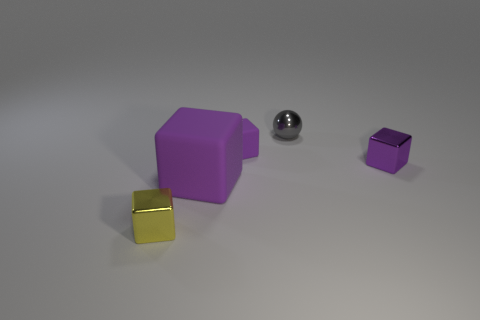How many purple cubes must be subtracted to get 1 purple cubes? 2 Subtract all small yellow blocks. How many blocks are left? 3 Add 1 large cyan cubes. How many objects exist? 6 Subtract all yellow blocks. How many blocks are left? 3 Subtract all balls. How many objects are left? 4 Add 3 purple blocks. How many purple blocks are left? 6 Add 1 gray spheres. How many gray spheres exist? 2 Subtract 0 green cylinders. How many objects are left? 5 Subtract 2 blocks. How many blocks are left? 2 Subtract all blue spheres. Subtract all yellow cylinders. How many spheres are left? 1 